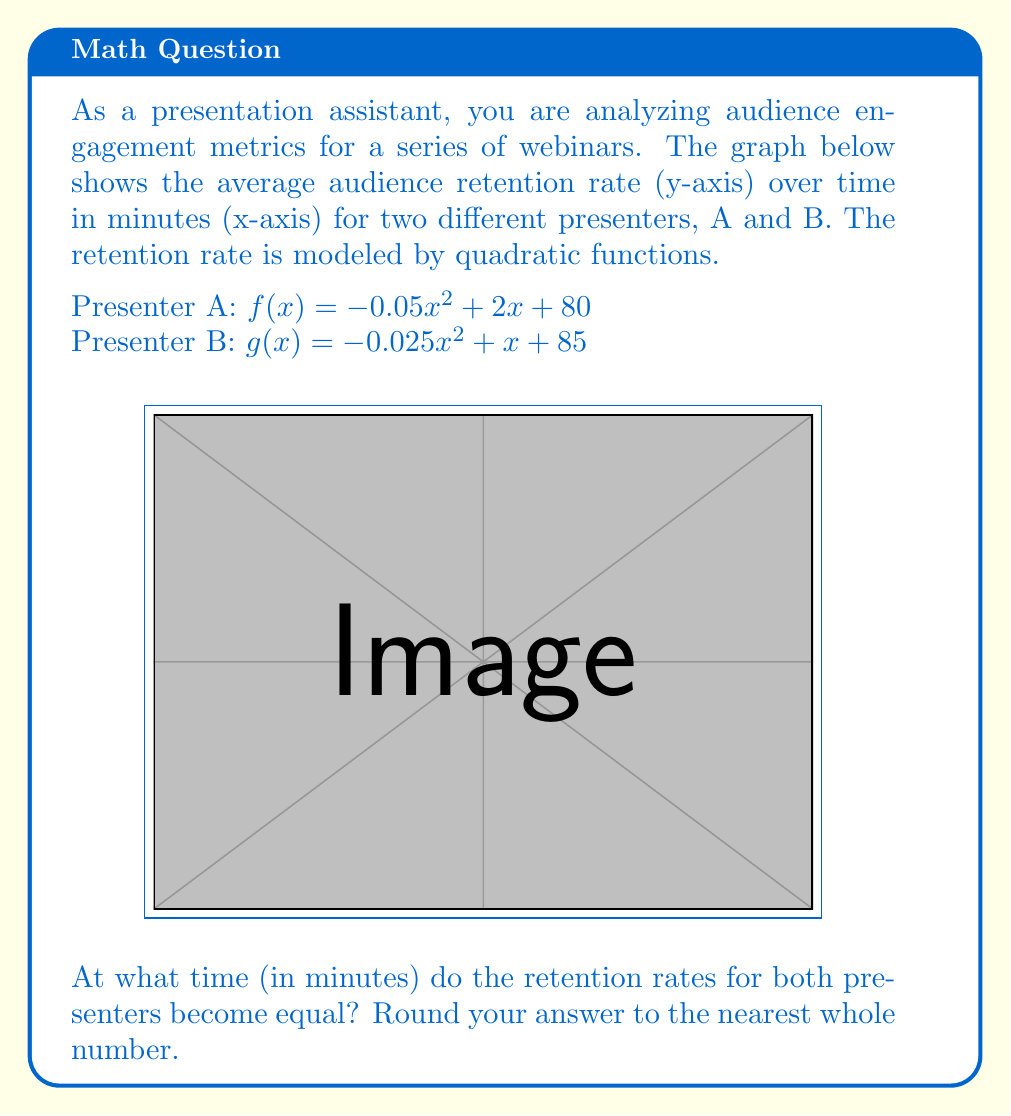Help me with this question. To find when the retention rates are equal, we need to solve the equation:

$f(x) = g(x)$

Substituting the given functions:

$-0.05x^2 + 2x + 80 = -0.025x^2 + x + 85$

Rearranging the equation:

$-0.025x^2 - x + 5 = 0$

Multiplying all terms by -40 to eliminate fractions:

$x^2 + 40x - 200 = 0$

This is a quadratic equation in the form $ax^2 + bx + c = 0$, where:
$a = 1$
$b = 40$
$c = -200$

We can solve this using the quadratic formula: $x = \frac{-b \pm \sqrt{b^2 - 4ac}}{2a}$

$x = \frac{-40 \pm \sqrt{40^2 - 4(1)(-200)}}{2(1)}$

$x = \frac{-40 \pm \sqrt{1600 + 800}}{2}$

$x = \frac{-40 \pm \sqrt{2400}}{2}$

$x = \frac{-40 \pm 48.99}{2}$

This gives us two solutions:
$x_1 = \frac{-40 + 48.99}{2} \approx 4.495$
$x_2 = \frac{-40 - 48.99}{2} \approx -44.495$

Since time cannot be negative, we discard the negative solution. Rounding to the nearest whole number, we get 4 minutes.

To verify, we can calculate the retention rates at 4 minutes:

For Presenter A: $f(4) = -0.05(4)^2 + 2(4) + 80 = 87.2\%$
For Presenter B: $g(4) = -0.025(4)^2 + 1(4) + 85 = 87.6\%$

These values are very close, confirming our solution.
Answer: 4 minutes 